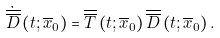Convert formula to latex. <formula><loc_0><loc_0><loc_500><loc_500>\dot { \overline { \overline { D } } } \left ( t ; \overline { x } _ { 0 } \right ) = \overline { \overline { T } } \left ( t ; \overline { x } _ { 0 } \right ) \overline { \overline { D } } \left ( t ; \overline { x } _ { 0 } \right ) .</formula> 